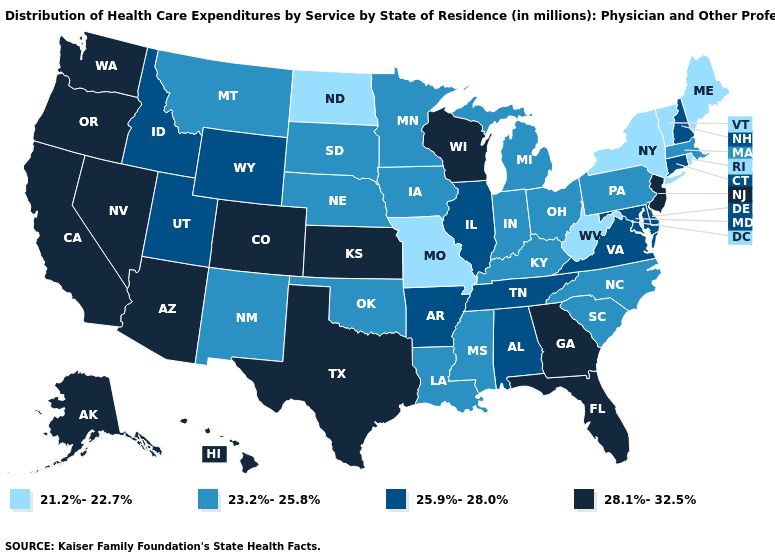Among the states that border Utah , does Idaho have the highest value?
Keep it brief. No. What is the lowest value in the USA?
Quick response, please. 21.2%-22.7%. Name the states that have a value in the range 28.1%-32.5%?
Answer briefly. Alaska, Arizona, California, Colorado, Florida, Georgia, Hawaii, Kansas, Nevada, New Jersey, Oregon, Texas, Washington, Wisconsin. Among the states that border Delaware , which have the lowest value?
Be succinct. Pennsylvania. Among the states that border Wisconsin , which have the lowest value?
Write a very short answer. Iowa, Michigan, Minnesota. Does Kentucky have a higher value than New Hampshire?
Answer briefly. No. Among the states that border Arizona , which have the highest value?
Answer briefly. California, Colorado, Nevada. What is the lowest value in states that border Connecticut?
Write a very short answer. 21.2%-22.7%. Which states have the highest value in the USA?
Write a very short answer. Alaska, Arizona, California, Colorado, Florida, Georgia, Hawaii, Kansas, Nevada, New Jersey, Oregon, Texas, Washington, Wisconsin. What is the highest value in the USA?
Concise answer only. 28.1%-32.5%. Name the states that have a value in the range 25.9%-28.0%?
Short answer required. Alabama, Arkansas, Connecticut, Delaware, Idaho, Illinois, Maryland, New Hampshire, Tennessee, Utah, Virginia, Wyoming. Name the states that have a value in the range 21.2%-22.7%?
Keep it brief. Maine, Missouri, New York, North Dakota, Rhode Island, Vermont, West Virginia. Which states have the lowest value in the West?
Quick response, please. Montana, New Mexico. Does Alaska have the highest value in the USA?
Quick response, please. Yes. Name the states that have a value in the range 28.1%-32.5%?
Be succinct. Alaska, Arizona, California, Colorado, Florida, Georgia, Hawaii, Kansas, Nevada, New Jersey, Oregon, Texas, Washington, Wisconsin. 